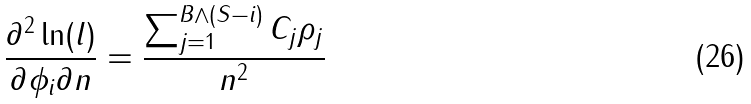<formula> <loc_0><loc_0><loc_500><loc_500>\frac { \partial ^ { 2 } \ln ( l ) } { \partial \phi _ { i } \partial n } = \frac { \sum _ { j = 1 } ^ { B \wedge ( S - i ) } C _ { j } \rho _ { j } } { n ^ { 2 } }</formula> 